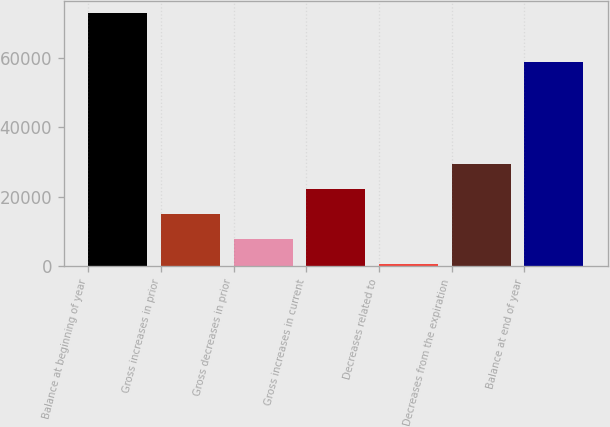Convert chart. <chart><loc_0><loc_0><loc_500><loc_500><bar_chart><fcel>Balance at beginning of year<fcel>Gross increases in prior<fcel>Gross decreases in prior<fcel>Gross increases in current<fcel>Decreases related to<fcel>Decreases from the expiration<fcel>Balance at end of year<nl><fcel>72878<fcel>15082<fcel>7857.5<fcel>22306.5<fcel>633<fcel>29531<fcel>58855<nl></chart> 